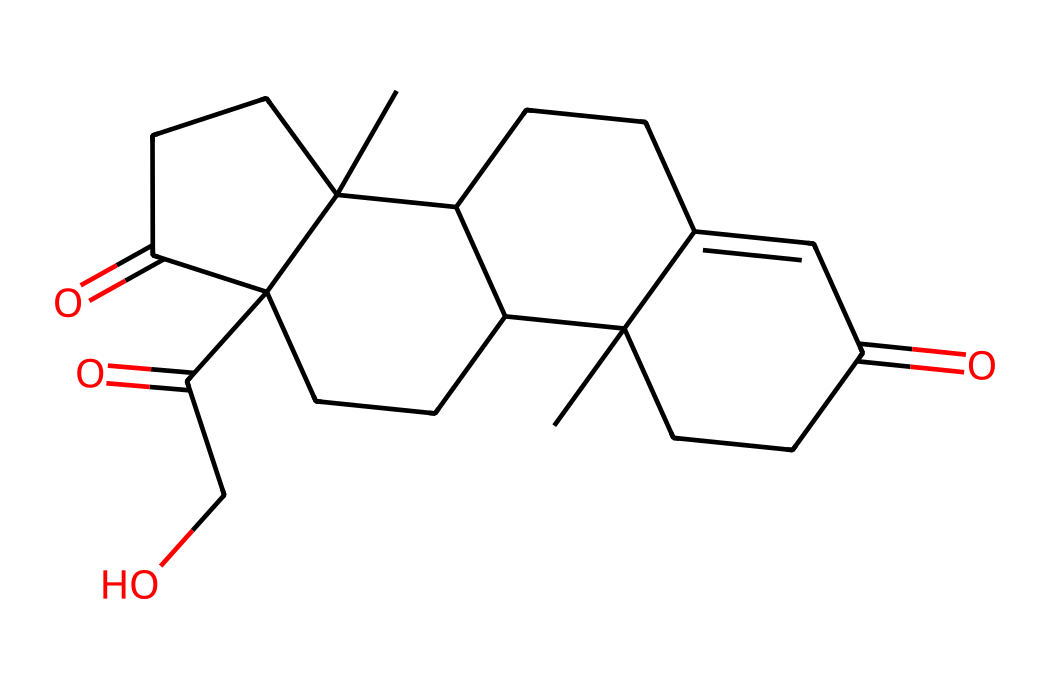What is the molecular formula of cortisol? To find the molecular formula, I need to count the number of carbon (C), hydrogen (H), and oxygen (O) atoms in the SMILES representation. Analyzing the structure, I find there are 21 carbon atoms, 30 hydrogen atoms, and 5 oxygen atoms, yielding the formula C21H30O5.
Answer: C21H30O5 How many oxygen atoms are present in cortisol? Counting the oxygen atoms in the SMILES structure, I see that there are 5 oxygen atoms in total.
Answer: 5 What type of hormone is cortisol classified as? Cortisol is categorized as a glucocorticoid hormone, which is a type of steroid hormone produced by the adrenal glands.
Answer: glucocorticoid How many rings are present in the steroid structure of cortisol? By examining the cyclic nature of the structure, I can identify four interconnected rings characteristic of steroid structures, which confirms that cortisol has four rings.
Answer: 4 Does cortisol contain any double bonds? By reviewing the SMILES representation, I can identify at least two instances of double bonds in the structure, confirming the presence of unsaturation.
Answer: yes What role does cortisol play in the body? Cortisol is primarily known for its role in the body's stress response, helping to regulate metabolism and immune response.
Answer: stress response 